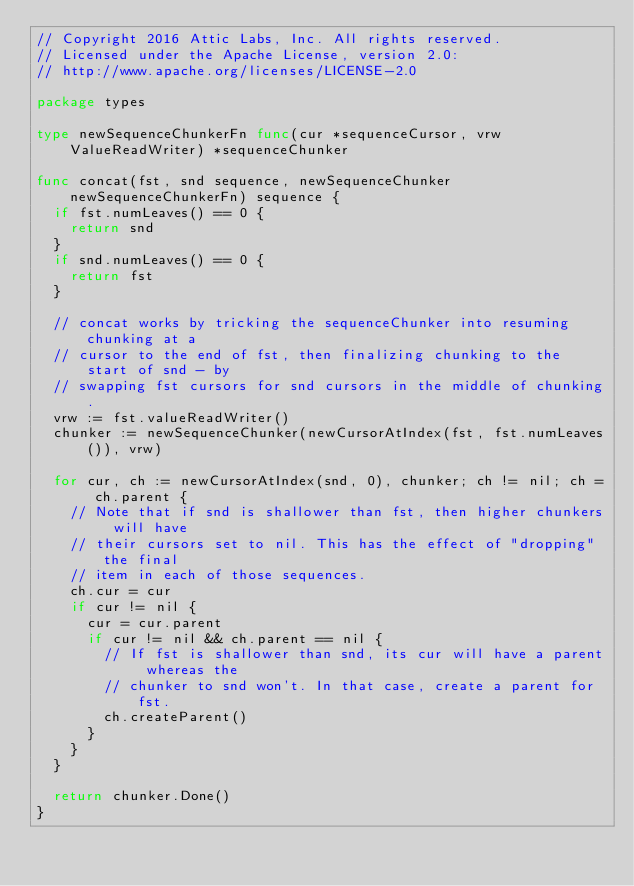Convert code to text. <code><loc_0><loc_0><loc_500><loc_500><_Go_>// Copyright 2016 Attic Labs, Inc. All rights reserved.
// Licensed under the Apache License, version 2.0:
// http://www.apache.org/licenses/LICENSE-2.0

package types

type newSequenceChunkerFn func(cur *sequenceCursor, vrw ValueReadWriter) *sequenceChunker

func concat(fst, snd sequence, newSequenceChunker newSequenceChunkerFn) sequence {
	if fst.numLeaves() == 0 {
		return snd
	}
	if snd.numLeaves() == 0 {
		return fst
	}

	// concat works by tricking the sequenceChunker into resuming chunking at a
	// cursor to the end of fst, then finalizing chunking to the start of snd - by
	// swapping fst cursors for snd cursors in the middle of chunking.
	vrw := fst.valueReadWriter()
	chunker := newSequenceChunker(newCursorAtIndex(fst, fst.numLeaves()), vrw)

	for cur, ch := newCursorAtIndex(snd, 0), chunker; ch != nil; ch = ch.parent {
		// Note that if snd is shallower than fst, then higher chunkers will have
		// their cursors set to nil. This has the effect of "dropping" the final
		// item in each of those sequences.
		ch.cur = cur
		if cur != nil {
			cur = cur.parent
			if cur != nil && ch.parent == nil {
				// If fst is shallower than snd, its cur will have a parent whereas the
				// chunker to snd won't. In that case, create a parent for fst.
				ch.createParent()
			}
		}
	}

	return chunker.Done()
}
</code> 